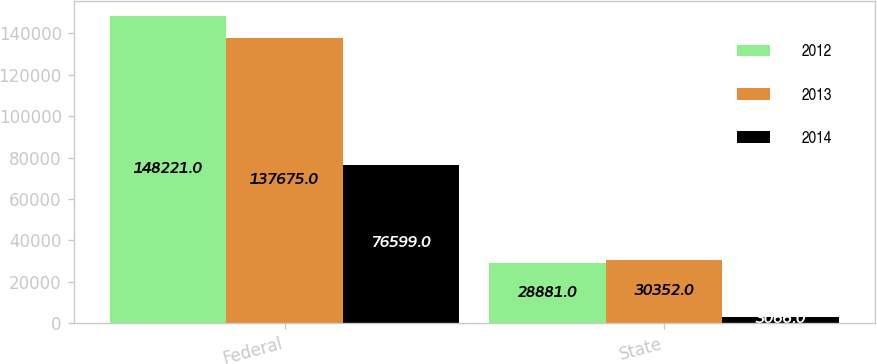Convert chart to OTSL. <chart><loc_0><loc_0><loc_500><loc_500><stacked_bar_chart><ecel><fcel>Federal<fcel>State<nl><fcel>2012<fcel>148221<fcel>28881<nl><fcel>2013<fcel>137675<fcel>30352<nl><fcel>2014<fcel>76599<fcel>3066<nl></chart> 